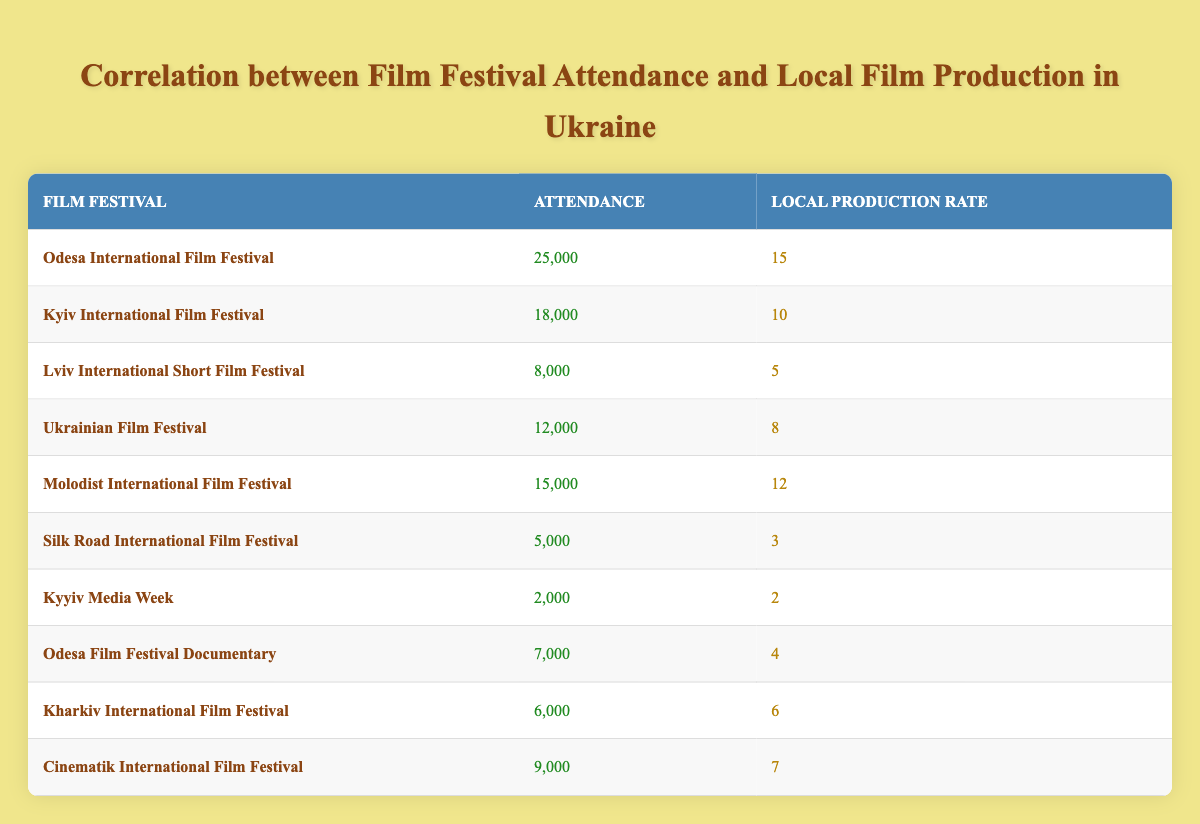What is the highest attendance at a film festival in Ukraine? The highest attendance recorded in the table is from the Odesa International Film Festival, which has 25,000 attendees.
Answer: 25,000 What is the local production rate for the Kyiv International Film Festival? According to the table, the local production rate for the Kyiv International Film Festival is 10.
Answer: 10 What is the average attendance at the festivals listed in the table? To find the average attendance, sum the attendances: 25000 + 18000 + 8000 + 12000 + 15000 + 5000 + 2000 + 7000 + 6000 + 9000 = 115000. There are 10 festivals, so the average is 115000 / 10 = 11500.
Answer: 11500 Is it true that the Lviv International Short Film Festival has a higher local production rate than the Silk Road International Film Festival? The Lviv International Short Film Festival has a local production rate of 5, and the Silk Road International Film Festival has a rate of 3. Since 5 is greater than 3, the statement is true.
Answer: Yes What is the difference in local production rate between the Odesa International Film Festival and the Kyyiv Media Week? The local production rate for the Odesa International Film Festival is 15, and for the Kyyiv Media Week, it is 2. To find the difference, subtract the lower from the higher: 15 - 2 = 13.
Answer: 13 Which festival has the lowest attendance and what is that number? The festival with the lowest attendance is the Kyyiv Media Week with an attendance of 2,000.
Answer: 2,000 Which festival has the highest local production rate, and what is that rate? The festival with the highest local production rate is the Odesa International Film Festival with a rate of 15.
Answer: 15 What is the sum of attendance for festivals with a local production rate of 12 or higher? The festivals with a local production rate of 12 or higher are the Odesa International Film Festival (25,000), Kyiv International Film Festival (18,000), and Molodist International Film Festival (15,000). Summing these: 25000 + 18000 + 15000 = 58000.
Answer: 58000 What is the local production rate for festivals with an attendance lower than 10,000? The festivals with attendance lower than 10,000 are the Silk Road International Film Festival (3), Kyyiv Media Week (2), Odesa Film Festival Documentary (4), Kharkiv International Film Festival (6), and Lviv International Short Film Festival (5). Summing their production rates gives: 3 + 2 + 4 + 6 + 5 = 20.
Answer: 20 